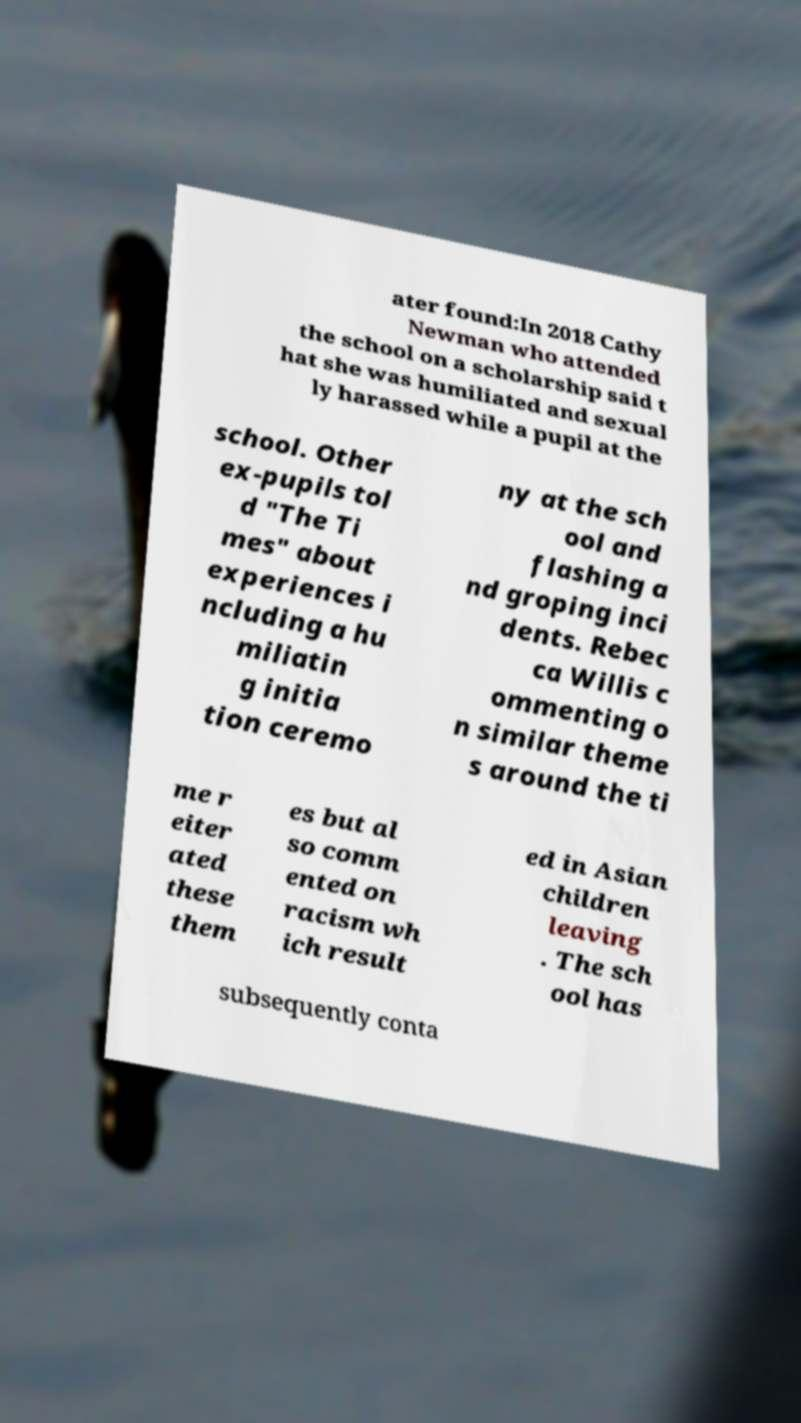Can you accurately transcribe the text from the provided image for me? ater found:In 2018 Cathy Newman who attended the school on a scholarship said t hat she was humiliated and sexual ly harassed while a pupil at the school. Other ex-pupils tol d "The Ti mes" about experiences i ncluding a hu miliatin g initia tion ceremo ny at the sch ool and flashing a nd groping inci dents. Rebec ca Willis c ommenting o n similar theme s around the ti me r eiter ated these them es but al so comm ented on racism wh ich result ed in Asian children leaving . The sch ool has subsequently conta 